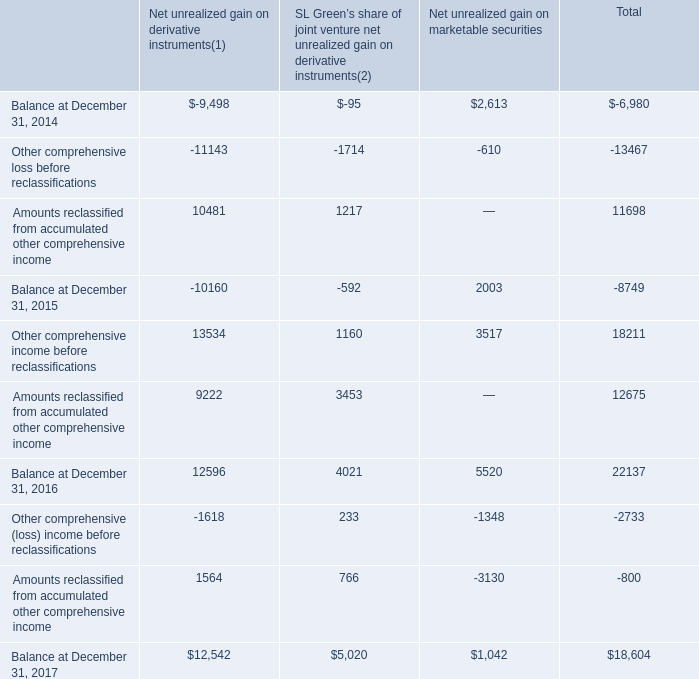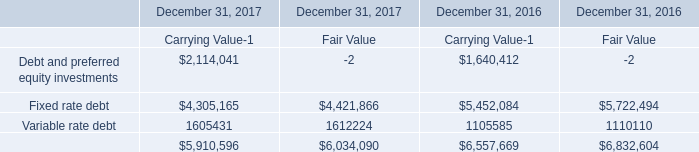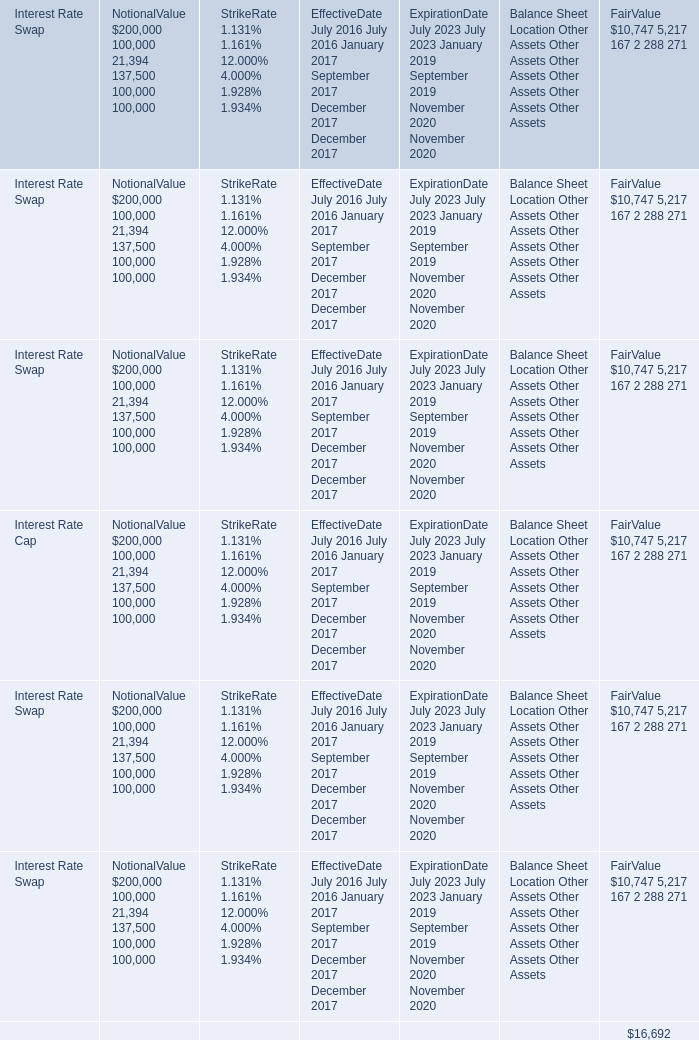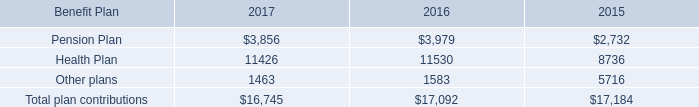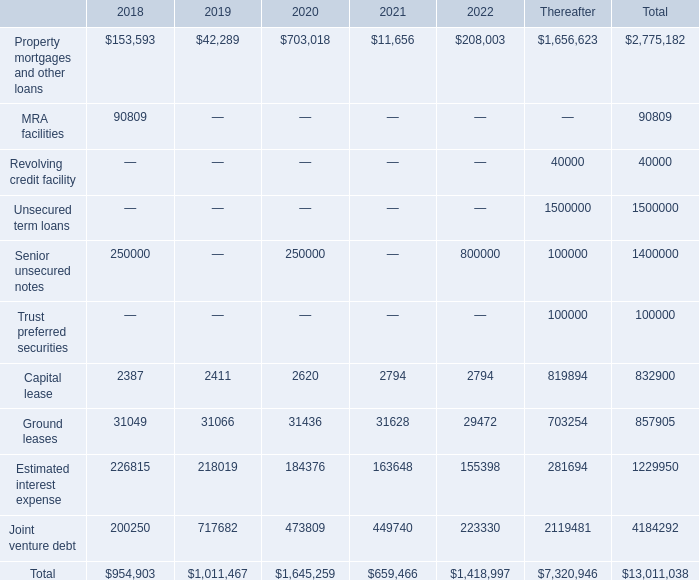what was the 2019 rate of decrease in estimated interest expense payments? 
Computations: ((226815 - 218019) / 226815)
Answer: 0.03878. 